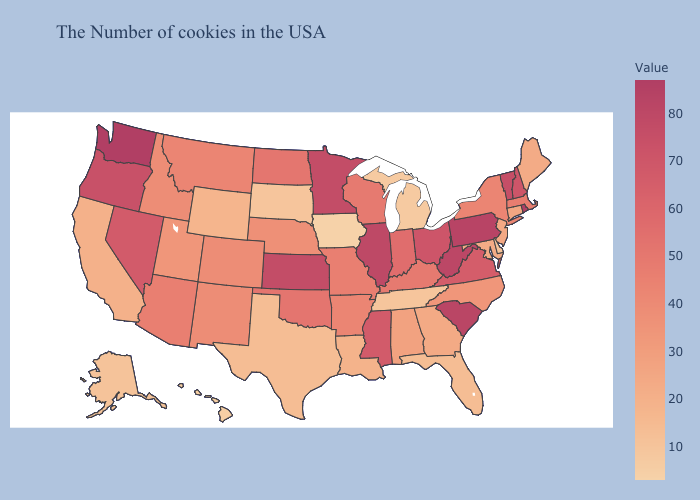Does Connecticut have the highest value in the USA?
Concise answer only. No. Which states have the highest value in the USA?
Give a very brief answer. Rhode Island, Washington. Among the states that border Vermont , does New York have the highest value?
Write a very short answer. No. Among the states that border South Carolina , does Georgia have the highest value?
Be succinct. No. Does Maine have the lowest value in the Northeast?
Write a very short answer. Yes. Does Tennessee have a higher value than North Dakota?
Keep it brief. No. Which states have the lowest value in the Northeast?
Give a very brief answer. Maine. Which states hav the highest value in the MidWest?
Quick response, please. Illinois. 